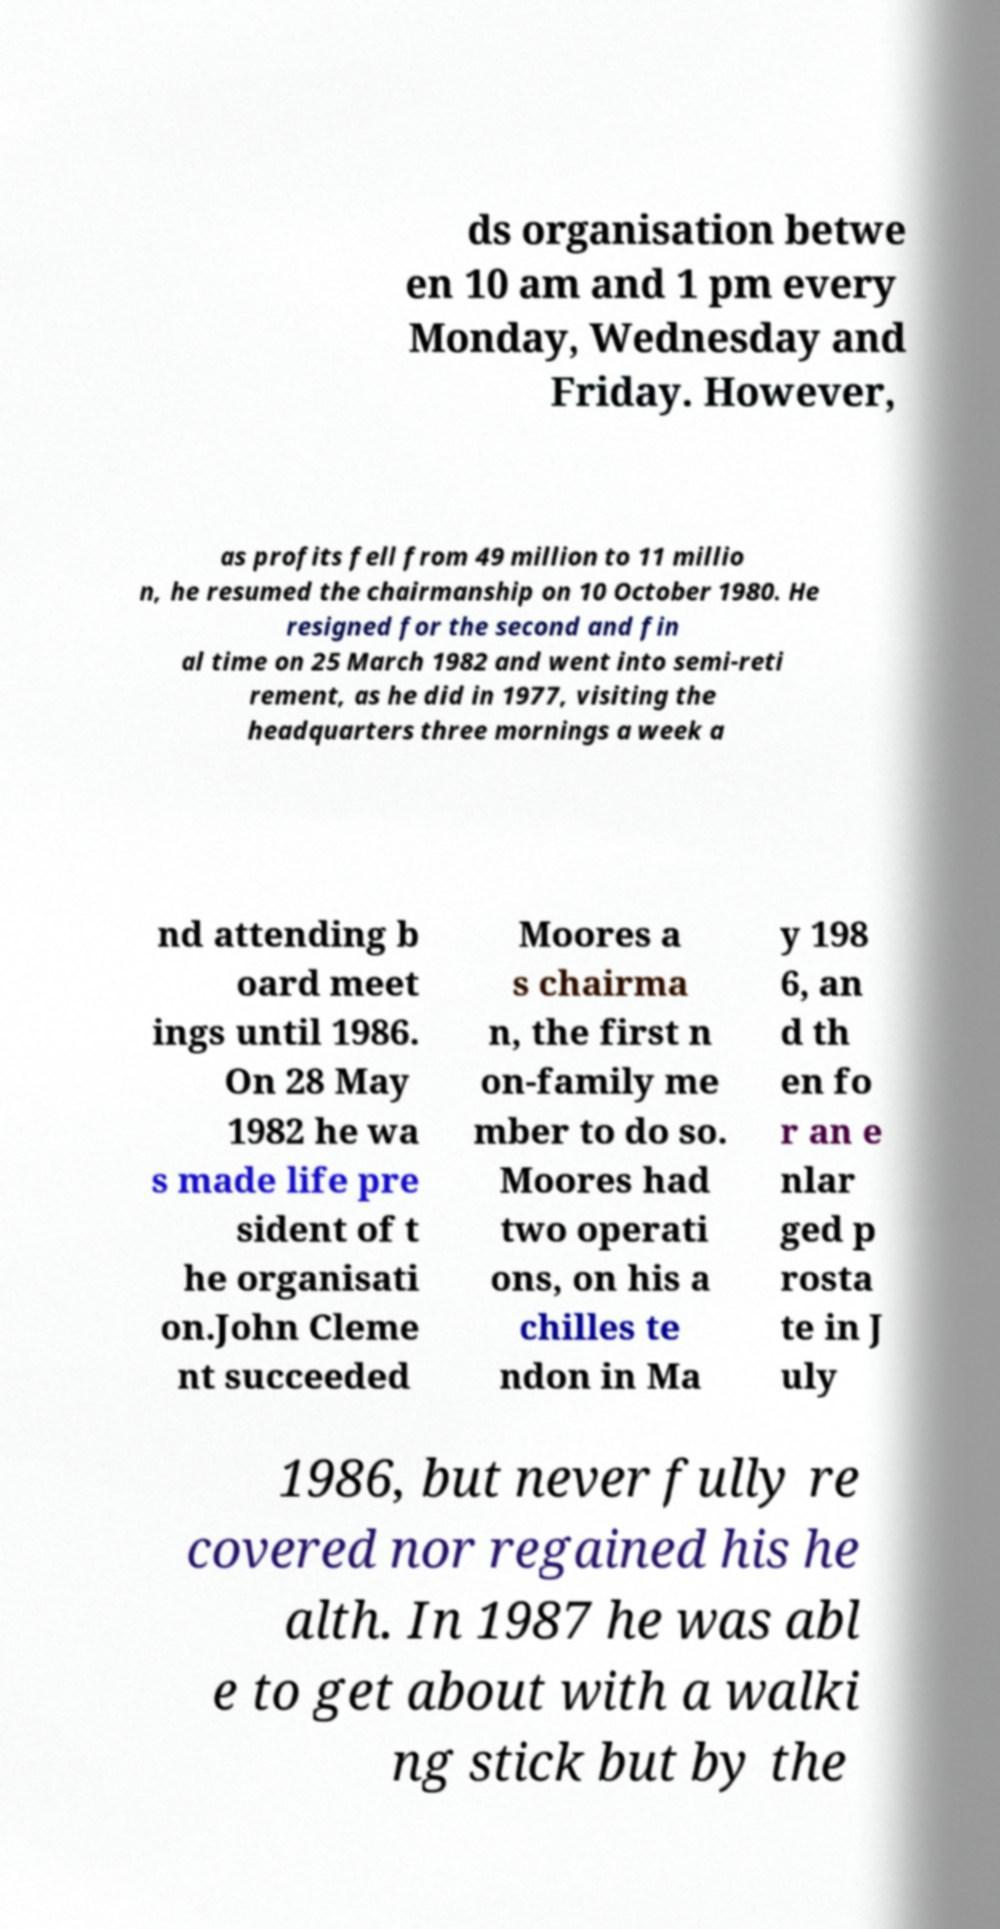Please read and relay the text visible in this image. What does it say? ds organisation betwe en 10 am and 1 pm every Monday, Wednesday and Friday. However, as profits fell from 49 million to 11 millio n, he resumed the chairmanship on 10 October 1980. He resigned for the second and fin al time on 25 March 1982 and went into semi-reti rement, as he did in 1977, visiting the headquarters three mornings a week a nd attending b oard meet ings until 1986. On 28 May 1982 he wa s made life pre sident of t he organisati on.John Cleme nt succeeded Moores a s chairma n, the first n on-family me mber to do so. Moores had two operati ons, on his a chilles te ndon in Ma y 198 6, an d th en fo r an e nlar ged p rosta te in J uly 1986, but never fully re covered nor regained his he alth. In 1987 he was abl e to get about with a walki ng stick but by the 